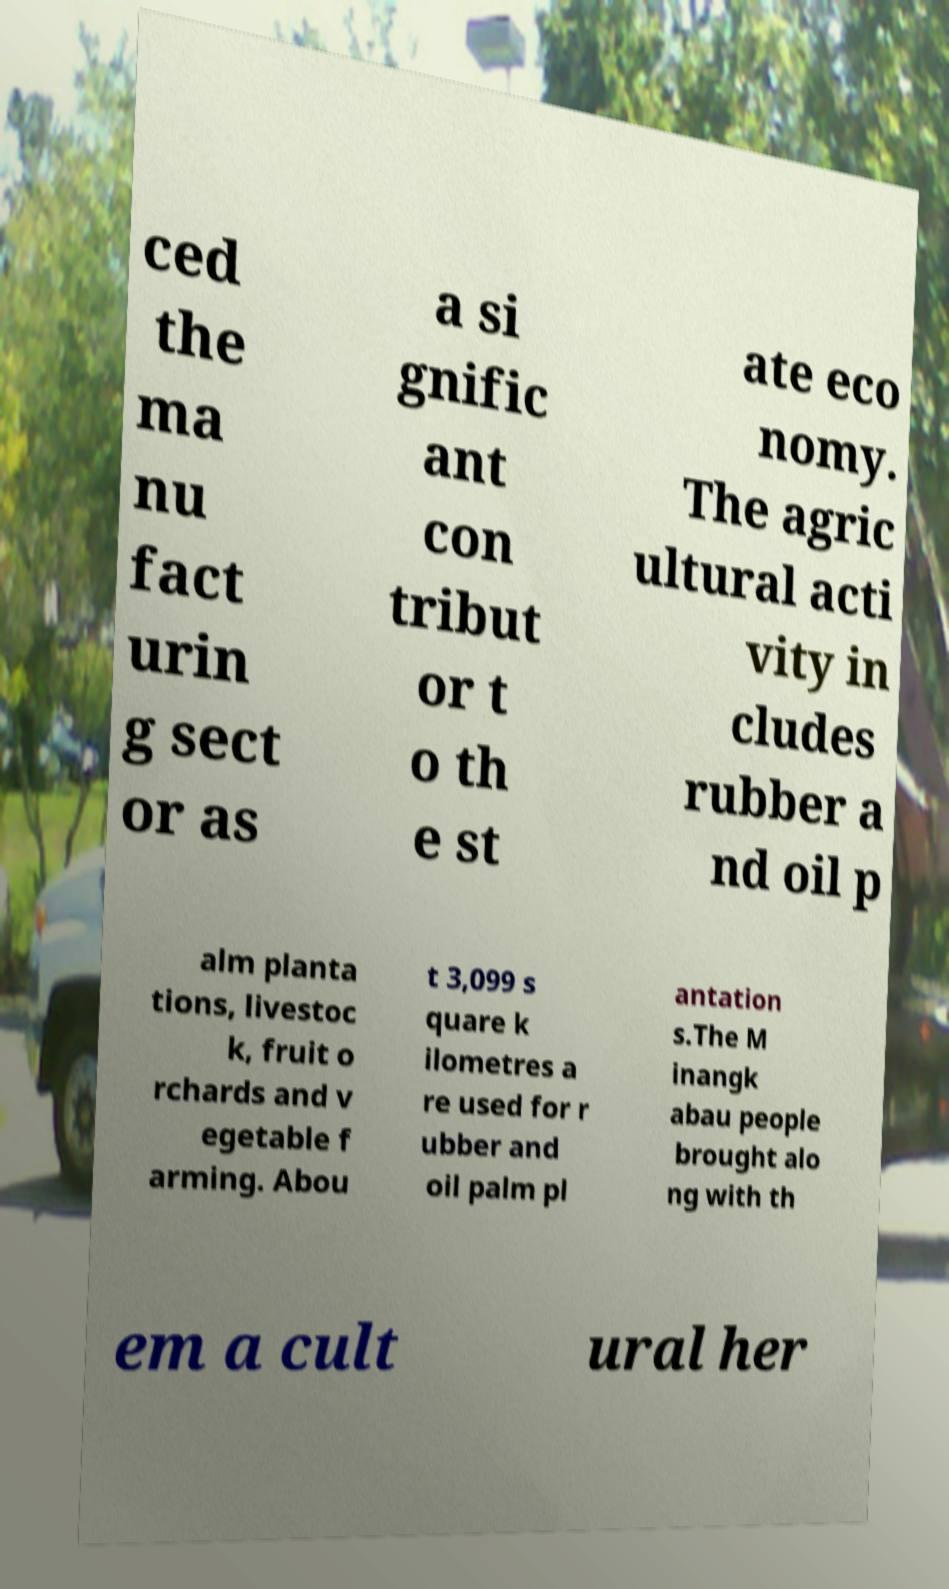What messages or text are displayed in this image? I need them in a readable, typed format. ced the ma nu fact urin g sect or as a si gnific ant con tribut or t o th e st ate eco nomy. The agric ultural acti vity in cludes rubber a nd oil p alm planta tions, livestoc k, fruit o rchards and v egetable f arming. Abou t 3,099 s quare k ilometres a re used for r ubber and oil palm pl antation s.The M inangk abau people brought alo ng with th em a cult ural her 